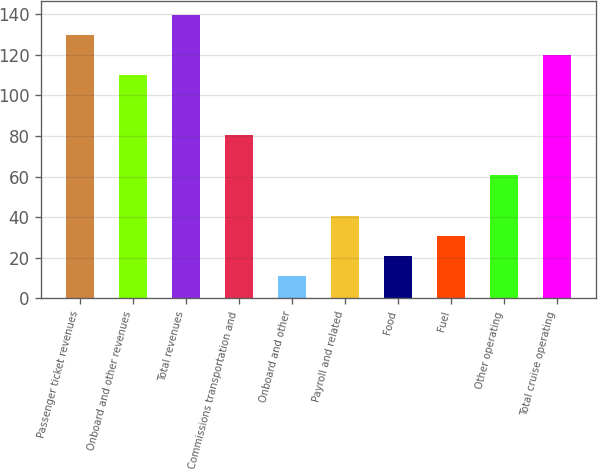Convert chart to OTSL. <chart><loc_0><loc_0><loc_500><loc_500><bar_chart><fcel>Passenger ticket revenues<fcel>Onboard and other revenues<fcel>Total revenues<fcel>Commissions transportation and<fcel>Onboard and other<fcel>Payroll and related<fcel>Food<fcel>Fuel<fcel>Other operating<fcel>Total cruise operating<nl><fcel>129.58<fcel>109.86<fcel>139.44<fcel>80.28<fcel>11.26<fcel>40.84<fcel>21.12<fcel>30.98<fcel>60.56<fcel>119.72<nl></chart> 